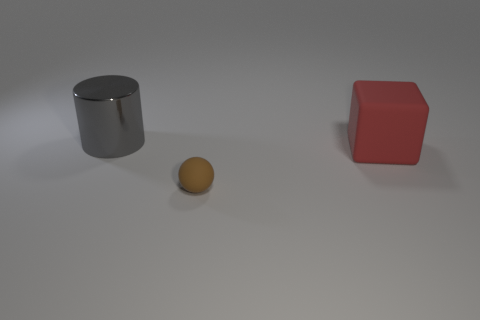Are there any purple cubes made of the same material as the sphere? Based on the image, there are no purple cubes present. We have a red cube and a metallic cylinder, along with a yellowish sphere. The red cube does not share the same material as the sphere. 